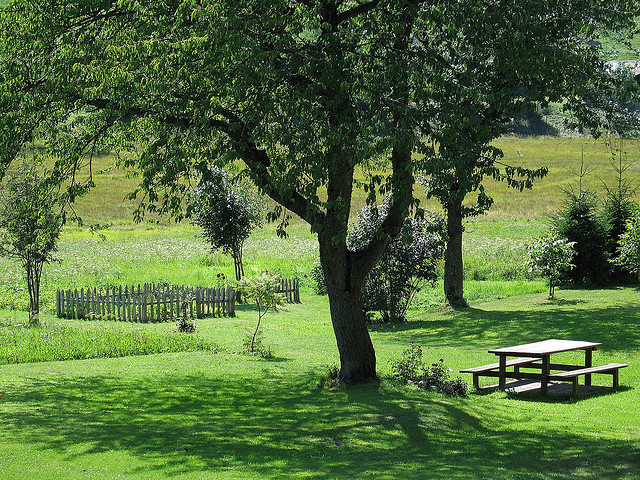<image>What type of trees are there? I am not sure what type of trees are there. It can be oak, cherry, fruit or fern. What type of trees are there? I don't know what type of trees are there. It can be deciduous, oak, fruit, fern, cherry, or something else. 